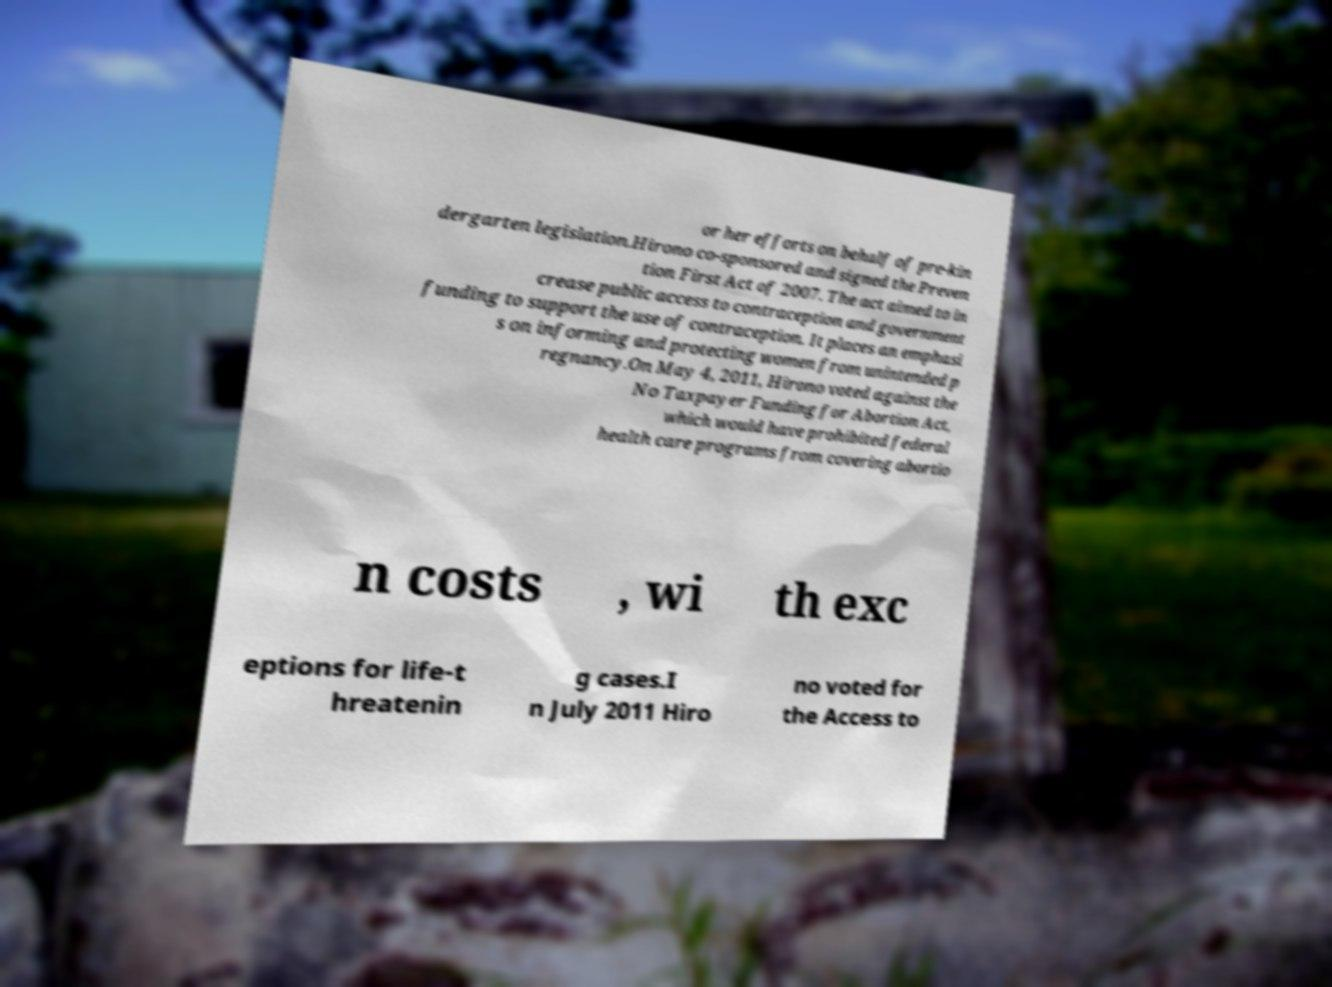Can you accurately transcribe the text from the provided image for me? or her efforts on behalf of pre-kin dergarten legislation.Hirono co-sponsored and signed the Preven tion First Act of 2007. The act aimed to in crease public access to contraception and government funding to support the use of contraception. It places an emphasi s on informing and protecting women from unintended p regnancy.On May 4, 2011, Hirono voted against the No Taxpayer Funding for Abortion Act, which would have prohibited federal health care programs from covering abortio n costs , wi th exc eptions for life-t hreatenin g cases.I n July 2011 Hiro no voted for the Access to 